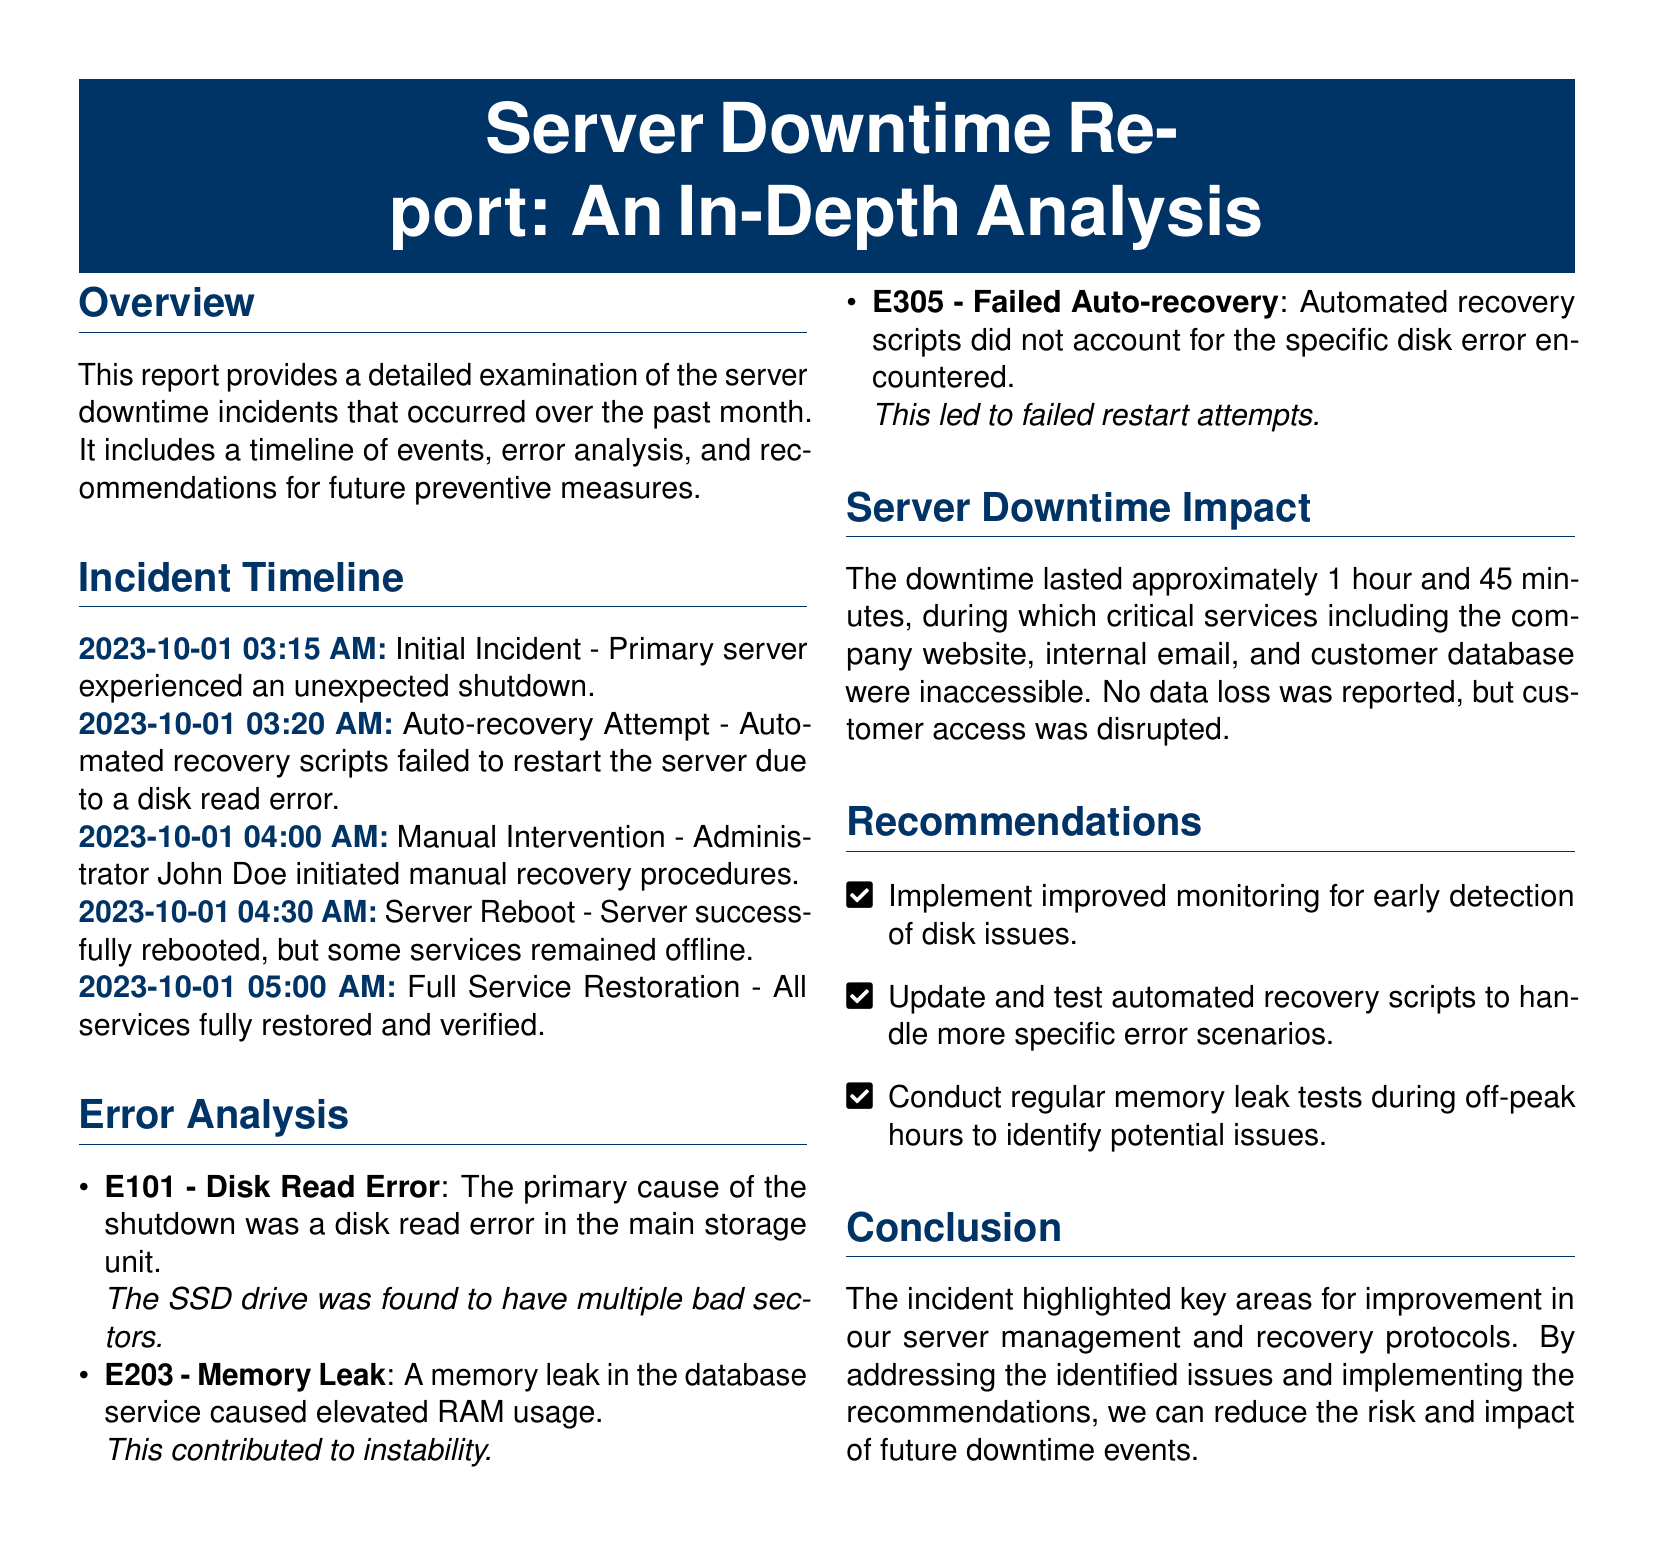what was the date of the initial incident? The initial incident occurred on October 1st, 2023.
Answer: 2023-10-01 who initiated the manual recovery procedures? The manual recovery procedures were initiated by Administrator John Doe.
Answer: John Doe how long did the downtime last? The downtime lasted approximately 1 hour and 45 minutes.
Answer: 1 hour and 45 minutes what caused the primary server shutdown? The primary cause of the shutdown was a disk read error.
Answer: disk read error what was one of the recommendations made in the report? One recommendation is to implement improved monitoring for early detection of disk issues.
Answer: improved monitoring how many error items were analyzed in the report? Three error items were analyzed in the report.
Answer: three what was the effect on access to services during the downtime? Critical services, including the company website and internal email, were inaccessible.
Answer: inaccessible what problem did the automated recovery scripts fail to address? The automated recovery scripts failed to account for the specific disk error encountered.
Answer: specific disk error 